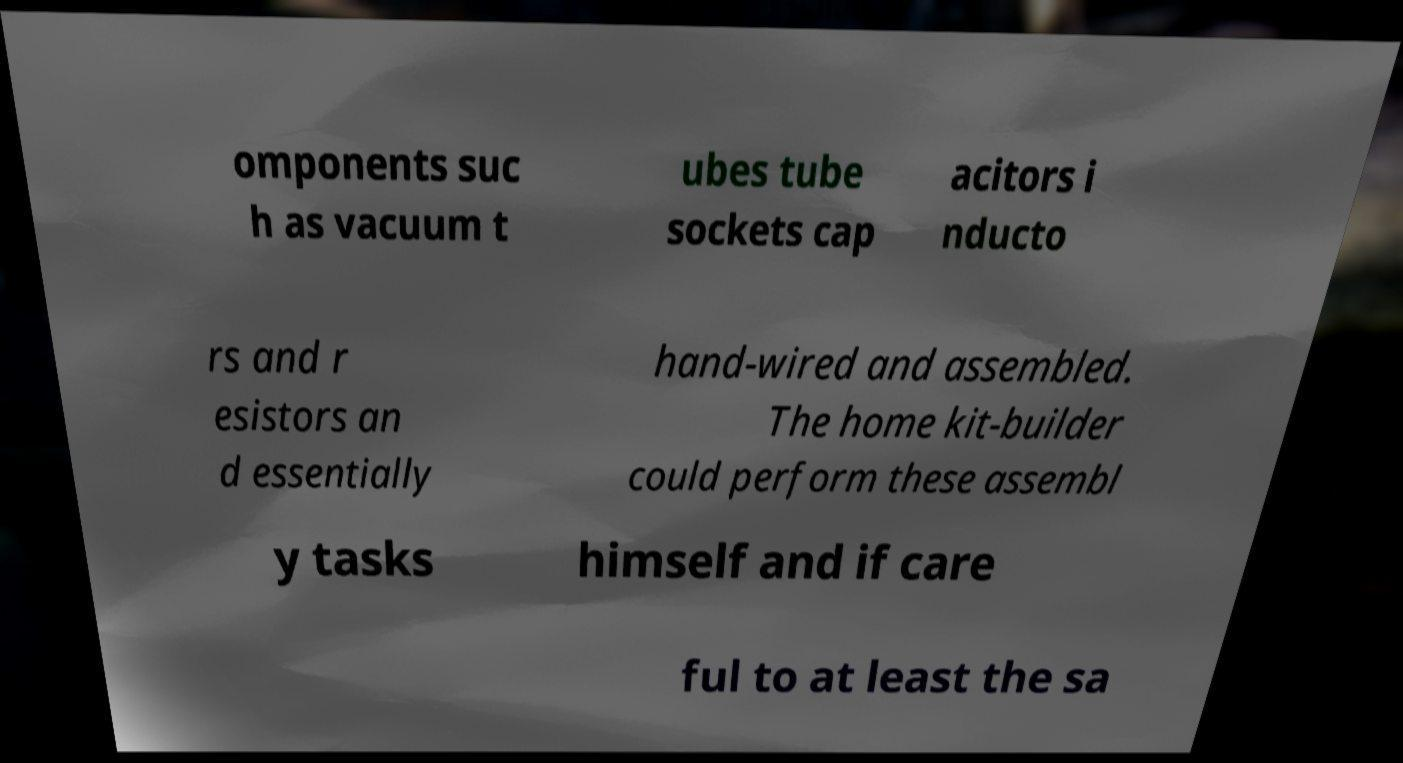Please identify and transcribe the text found in this image. omponents suc h as vacuum t ubes tube sockets cap acitors i nducto rs and r esistors an d essentially hand-wired and assembled. The home kit-builder could perform these assembl y tasks himself and if care ful to at least the sa 